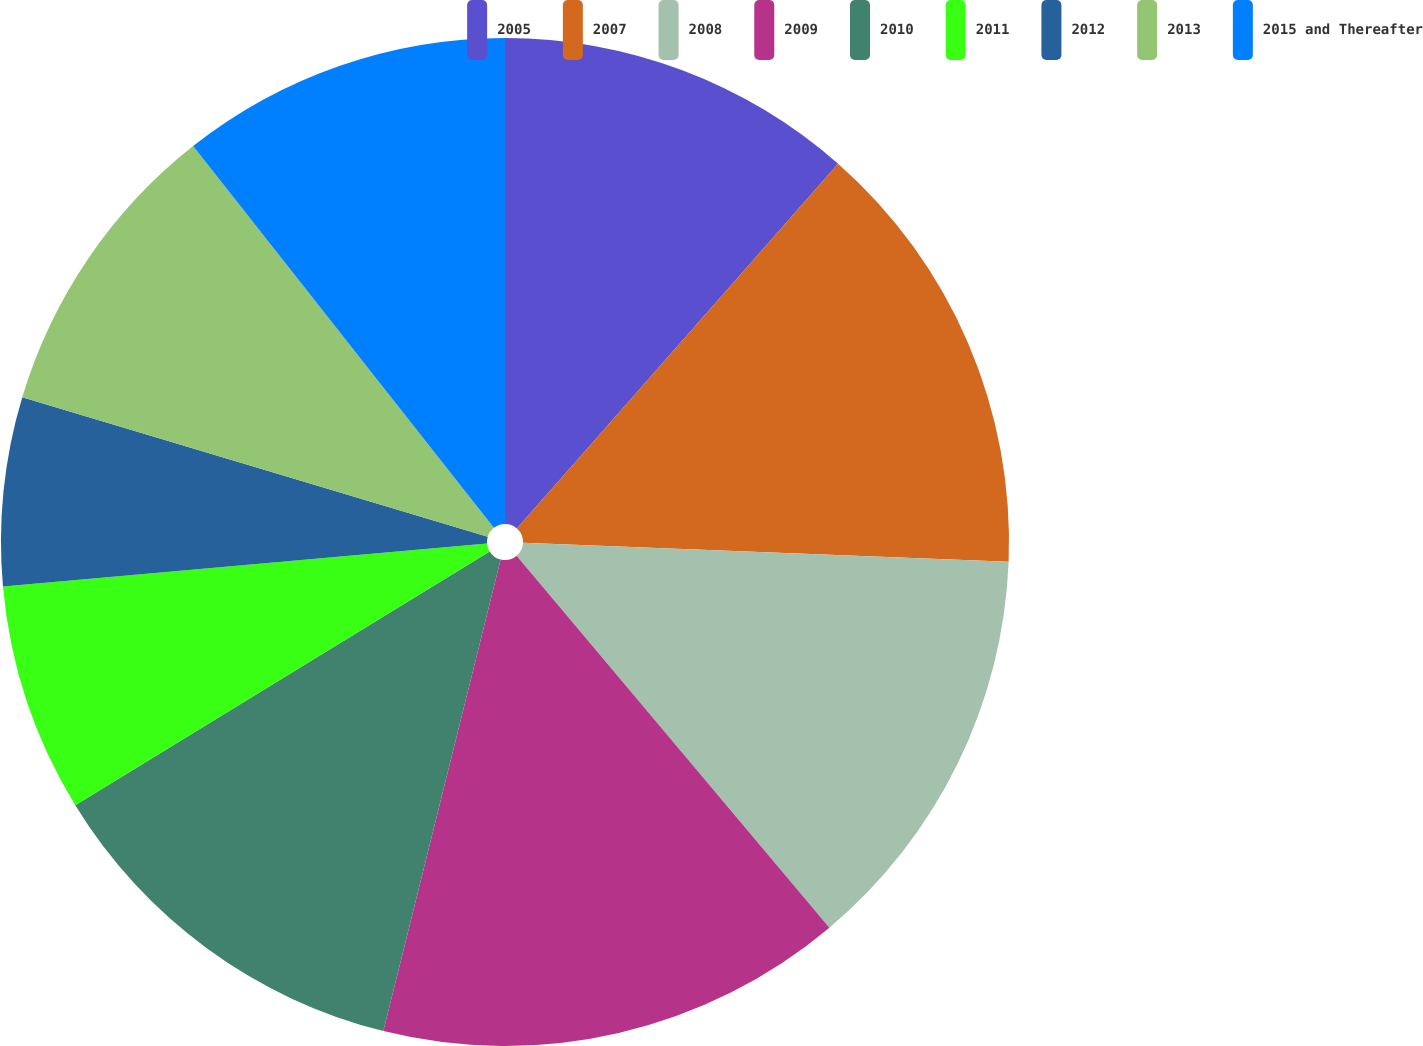Convert chart to OTSL. <chart><loc_0><loc_0><loc_500><loc_500><pie_chart><fcel>2005<fcel>2007<fcel>2008<fcel>2009<fcel>2010<fcel>2011<fcel>2012<fcel>2013<fcel>2015 and Thereafter<nl><fcel>11.49%<fcel>14.13%<fcel>13.25%<fcel>15.01%<fcel>12.37%<fcel>7.34%<fcel>6.05%<fcel>9.74%<fcel>10.62%<nl></chart> 